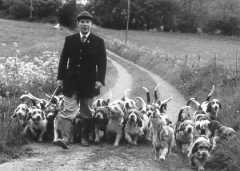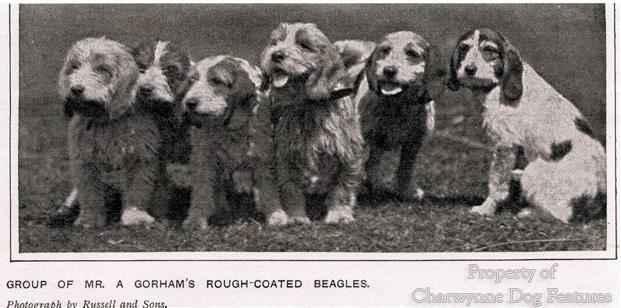The first image is the image on the left, the second image is the image on the right. Analyze the images presented: Is the assertion "Both images show at least one person standing behind a pack of hound dogs." valid? Answer yes or no. No. The first image is the image on the left, the second image is the image on the right. Assess this claim about the two images: "There are at most one human near dogs in the image pair.". Correct or not? Answer yes or no. Yes. 